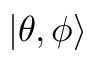Convert formula to latex. <formula><loc_0><loc_0><loc_500><loc_500>| \theta , \phi \rangle</formula> 